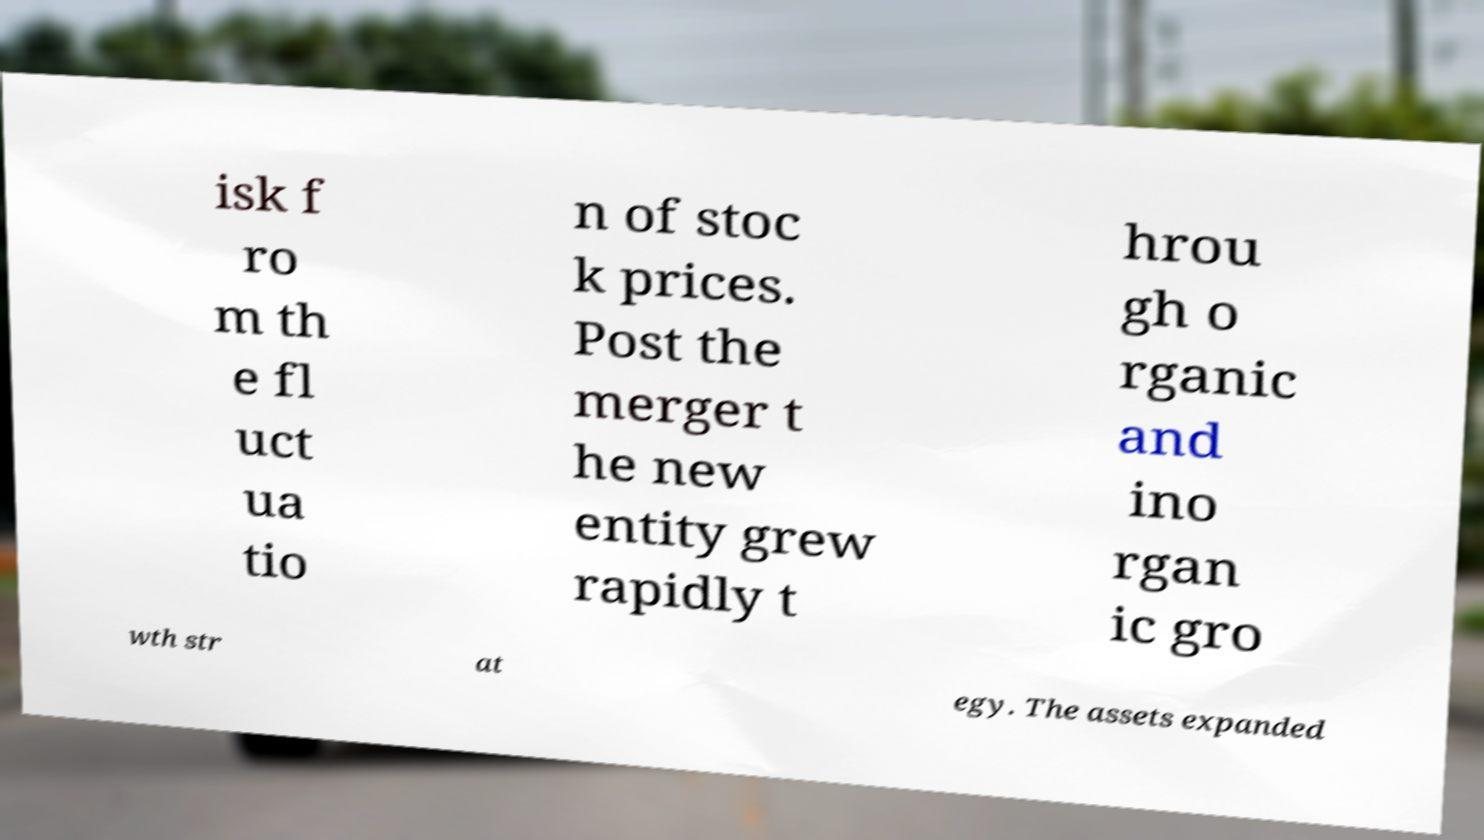Could you extract and type out the text from this image? isk f ro m th e fl uct ua tio n of stoc k prices. Post the merger t he new entity grew rapidly t hrou gh o rganic and ino rgan ic gro wth str at egy. The assets expanded 